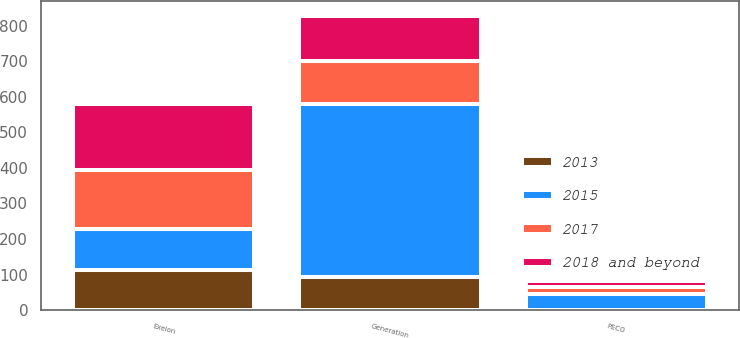<chart> <loc_0><loc_0><loc_500><loc_500><stacked_bar_chart><ecel><fcel>Exelon<fcel>Generation<fcel>PECO<nl><fcel>2015<fcel>114<fcel>487<fcel>45<nl><fcel>2018 and beyond<fcel>186<fcel>127<fcel>17<nl><fcel>2017<fcel>167<fcel>120<fcel>18<nl><fcel>2013<fcel>114<fcel>94<fcel>1<nl></chart> 